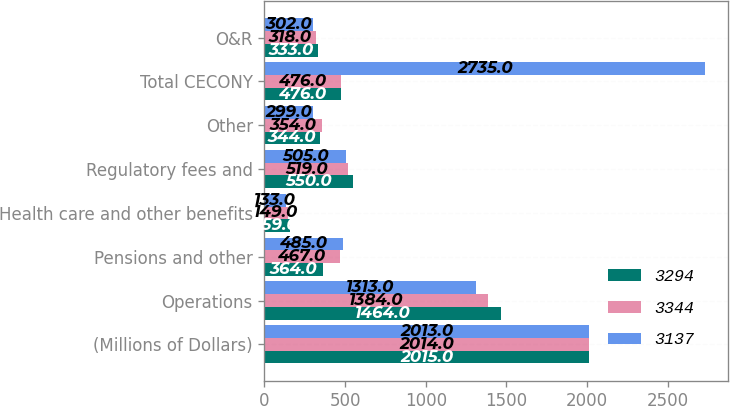<chart> <loc_0><loc_0><loc_500><loc_500><stacked_bar_chart><ecel><fcel>(Millions of Dollars)<fcel>Operations<fcel>Pensions and other<fcel>Health care and other benefits<fcel>Regulatory fees and<fcel>Other<fcel>Total CECONY<fcel>O&R<nl><fcel>3294<fcel>2015<fcel>1464<fcel>364<fcel>159<fcel>550<fcel>344<fcel>476<fcel>333<nl><fcel>3344<fcel>2014<fcel>1384<fcel>467<fcel>149<fcel>519<fcel>354<fcel>476<fcel>318<nl><fcel>3137<fcel>2013<fcel>1313<fcel>485<fcel>133<fcel>505<fcel>299<fcel>2735<fcel>302<nl></chart> 